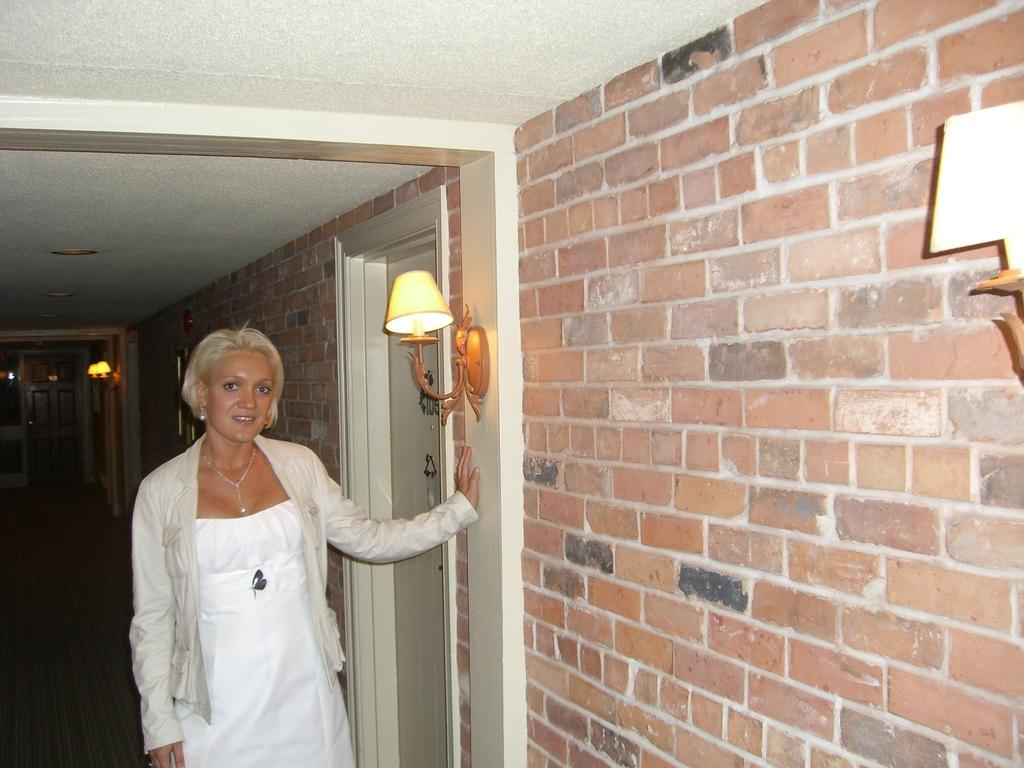Who is present in the image? There is a woman in the picture. What is the woman's position in relation to the wall? The woman is standing near a wall. What can be seen on the wall? There are lamps on the wall. What architectural feature is visible in the image? There is a door in the picture. What type of statement is the woman making in the image? There is no indication in the image that the woman is making a statement. What color is the linen draped over the door in the image? There is: There is no linen draped over the door in the image. 